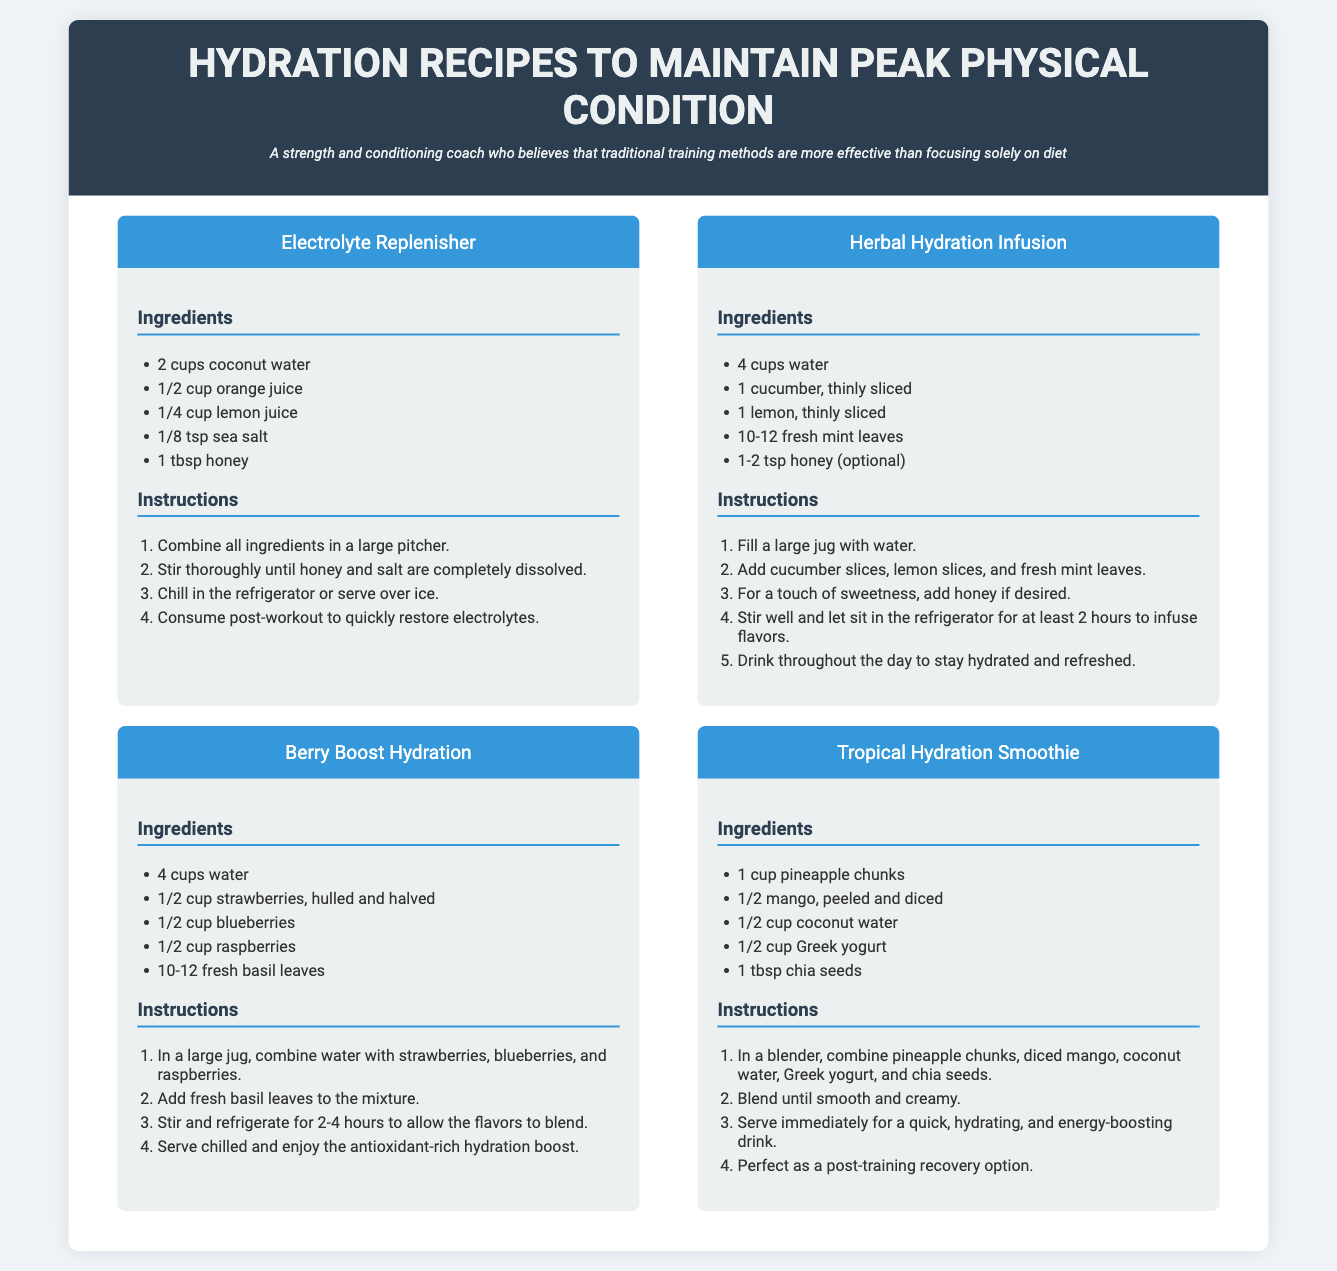What is the main title of the document? The main title of the document is prominently displayed at the top and defines the topic clearly.
Answer: Hydration Recipes to Maintain Peak Physical Condition How many recipes are included in the document? The document presents a collection of hydration recipes, making it easy to identify the total number of recipes visually.
Answer: Four What ingredient is included in the Electrolyte Replenisher recipe? The document lists specific ingredients for each recipe, allowing for easy retrieval of each ingredient.
Answer: Coconut water What is the optional ingredient in the Herbal Hydration Infusion? The optional ingredients are specified in the recipe section, highlighting flexibility in preparation.
Answer: Honey How long should the Herbal Hydration Infusion sit to infuse flavors? The instructions for each recipe provide clear guidance on preparation times, including infusion times for ingredients.
Answer: Two hours What ingredient is used in the Tropical Hydration Smoothie? Each recipe lists multiple ingredients, allowing for the identification of a specific ingredient easily.
Answer: Pineapple chunks What is one of the health benefits of the Berry Boost Hydration? The document emphasizes benefits related to hydration, particularly in the context of physical condition.
Answer: Antioxidant-rich What do you need to do with the ingredients for the Electrolyte Replenisher before consumption? The instructions provide steps necessary to prepare each recipe for consumption effectively.
Answer: Stir thoroughly Which herb is used in the Berry Boost Hydration recipe? The recipes include the use of fresh herbs, which contribute to flavor and health benefits.
Answer: Basil 